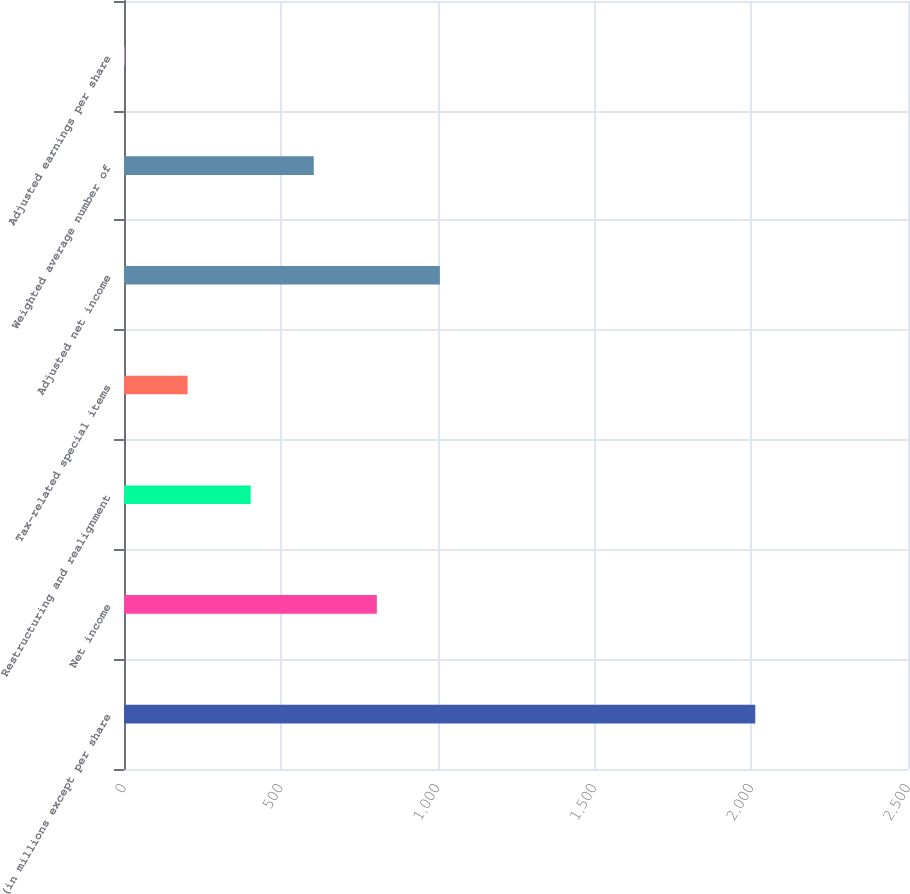<chart> <loc_0><loc_0><loc_500><loc_500><bar_chart><fcel>(in millions except per share<fcel>Net income<fcel>Restructuring and realignment<fcel>Tax-related special items<fcel>Adjusted net income<fcel>Weighted average number of<fcel>Adjusted earnings per share<nl><fcel>2013<fcel>806.19<fcel>403.93<fcel>202.8<fcel>1007.32<fcel>605.06<fcel>1.67<nl></chart> 